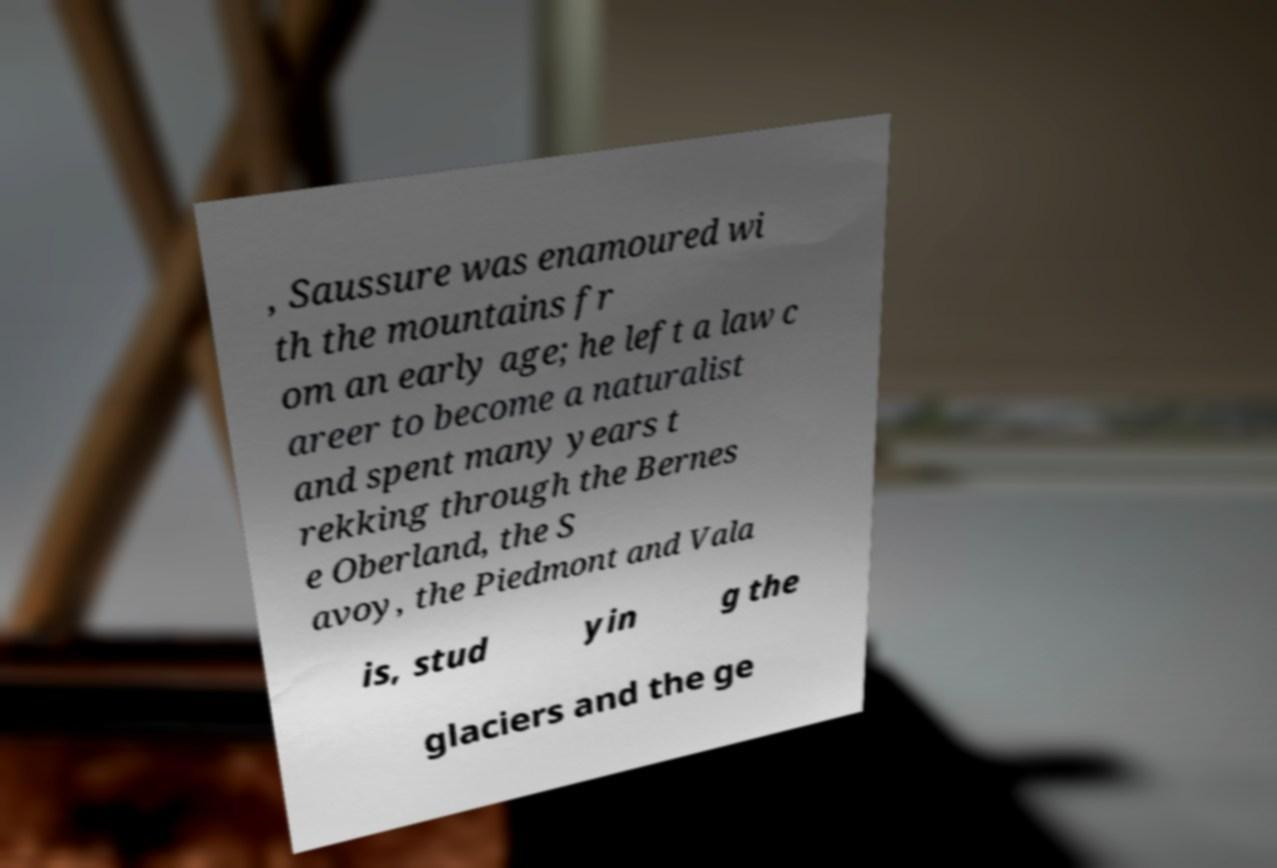For documentation purposes, I need the text within this image transcribed. Could you provide that? , Saussure was enamoured wi th the mountains fr om an early age; he left a law c areer to become a naturalist and spent many years t rekking through the Bernes e Oberland, the S avoy, the Piedmont and Vala is, stud yin g the glaciers and the ge 